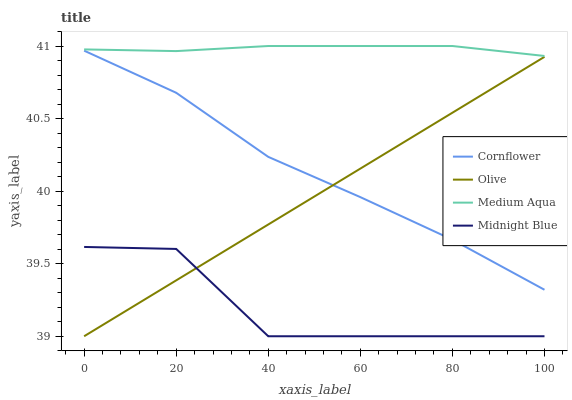Does Midnight Blue have the minimum area under the curve?
Answer yes or no. Yes. Does Medium Aqua have the maximum area under the curve?
Answer yes or no. Yes. Does Cornflower have the minimum area under the curve?
Answer yes or no. No. Does Cornflower have the maximum area under the curve?
Answer yes or no. No. Is Olive the smoothest?
Answer yes or no. Yes. Is Midnight Blue the roughest?
Answer yes or no. Yes. Is Cornflower the smoothest?
Answer yes or no. No. Is Cornflower the roughest?
Answer yes or no. No. Does Olive have the lowest value?
Answer yes or no. Yes. Does Cornflower have the lowest value?
Answer yes or no. No. Does Medium Aqua have the highest value?
Answer yes or no. Yes. Does Cornflower have the highest value?
Answer yes or no. No. Is Midnight Blue less than Cornflower?
Answer yes or no. Yes. Is Cornflower greater than Midnight Blue?
Answer yes or no. Yes. Does Olive intersect Midnight Blue?
Answer yes or no. Yes. Is Olive less than Midnight Blue?
Answer yes or no. No. Is Olive greater than Midnight Blue?
Answer yes or no. No. Does Midnight Blue intersect Cornflower?
Answer yes or no. No. 